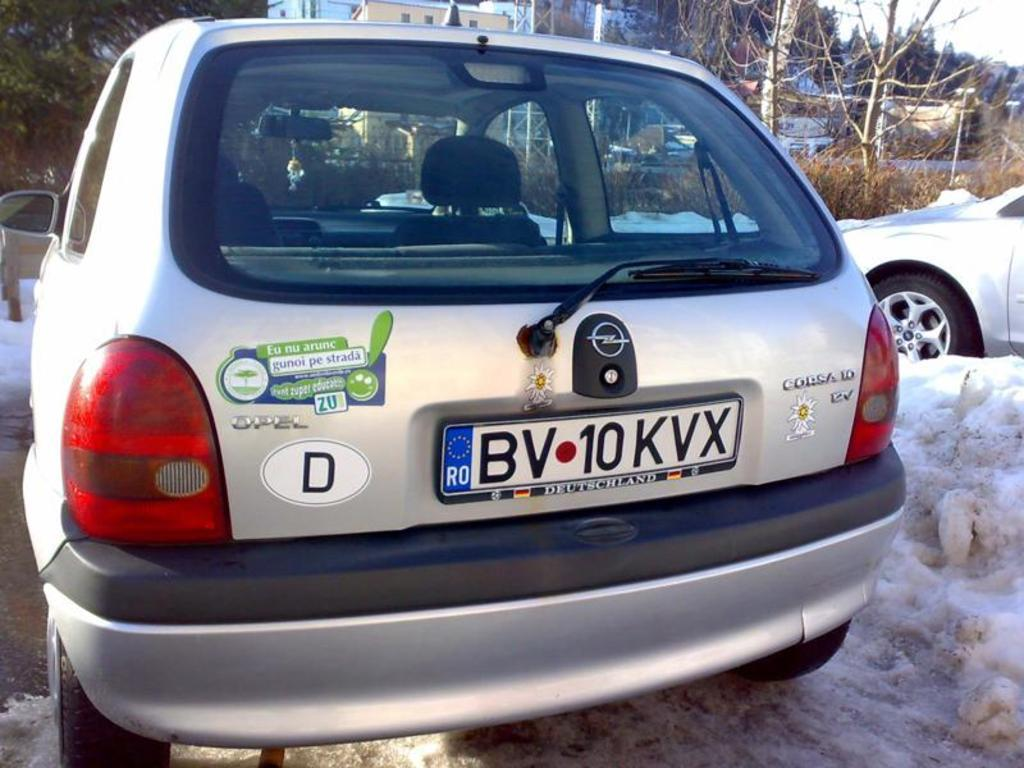<image>
Give a short and clear explanation of the subsequent image. An Opel brand Corsa with a tag that reads BV 10 KVX. 